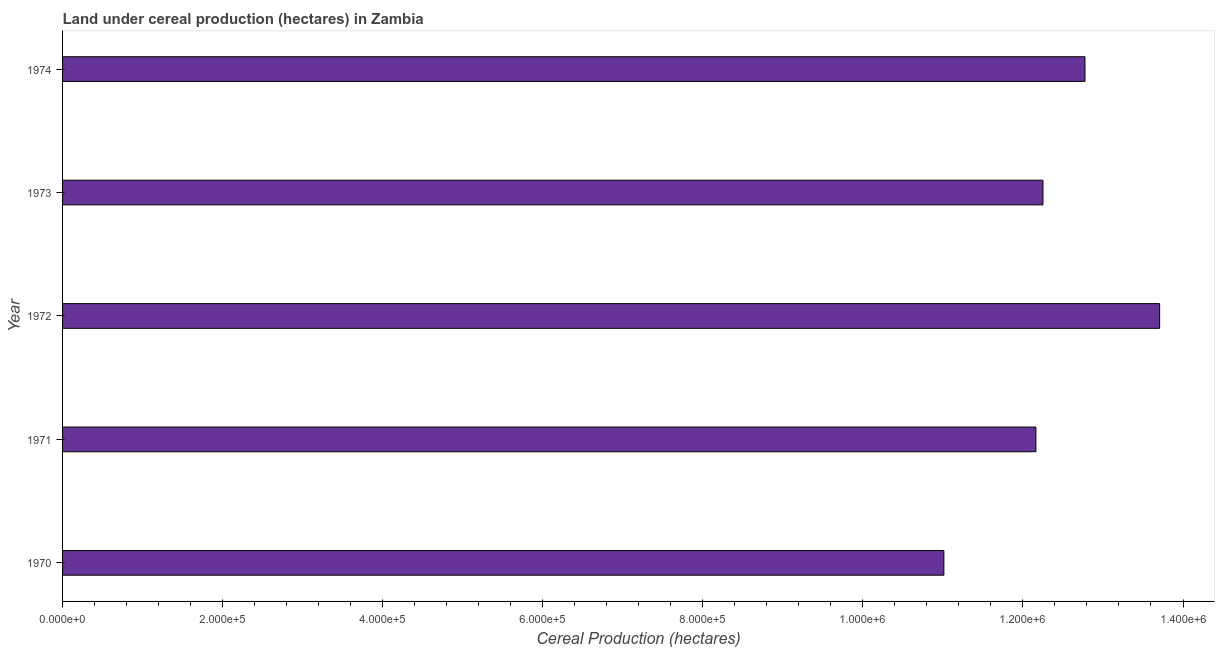What is the title of the graph?
Make the answer very short. Land under cereal production (hectares) in Zambia. What is the label or title of the X-axis?
Provide a short and direct response. Cereal Production (hectares). What is the land under cereal production in 1973?
Offer a very short reply. 1.22e+06. Across all years, what is the maximum land under cereal production?
Provide a short and direct response. 1.37e+06. Across all years, what is the minimum land under cereal production?
Your answer should be compact. 1.10e+06. In which year was the land under cereal production maximum?
Offer a terse response. 1972. What is the sum of the land under cereal production?
Provide a succinct answer. 6.19e+06. What is the difference between the land under cereal production in 1972 and 1974?
Your response must be concise. 9.33e+04. What is the average land under cereal production per year?
Ensure brevity in your answer.  1.24e+06. What is the median land under cereal production?
Make the answer very short. 1.22e+06. What is the difference between the highest and the second highest land under cereal production?
Ensure brevity in your answer.  9.33e+04. Is the sum of the land under cereal production in 1972 and 1973 greater than the maximum land under cereal production across all years?
Offer a very short reply. Yes. What is the difference between the highest and the lowest land under cereal production?
Provide a succinct answer. 2.70e+05. In how many years, is the land under cereal production greater than the average land under cereal production taken over all years?
Your answer should be very brief. 2. How many bars are there?
Your response must be concise. 5. What is the Cereal Production (hectares) of 1970?
Keep it short and to the point. 1.10e+06. What is the Cereal Production (hectares) of 1971?
Give a very brief answer. 1.22e+06. What is the Cereal Production (hectares) of 1972?
Provide a succinct answer. 1.37e+06. What is the Cereal Production (hectares) in 1973?
Ensure brevity in your answer.  1.22e+06. What is the Cereal Production (hectares) in 1974?
Give a very brief answer. 1.28e+06. What is the difference between the Cereal Production (hectares) in 1970 and 1971?
Provide a short and direct response. -1.15e+05. What is the difference between the Cereal Production (hectares) in 1970 and 1972?
Your answer should be very brief. -2.70e+05. What is the difference between the Cereal Production (hectares) in 1970 and 1973?
Your answer should be very brief. -1.24e+05. What is the difference between the Cereal Production (hectares) in 1970 and 1974?
Give a very brief answer. -1.76e+05. What is the difference between the Cereal Production (hectares) in 1971 and 1972?
Provide a short and direct response. -1.55e+05. What is the difference between the Cereal Production (hectares) in 1971 and 1973?
Make the answer very short. -8795. What is the difference between the Cereal Production (hectares) in 1971 and 1974?
Provide a succinct answer. -6.13e+04. What is the difference between the Cereal Production (hectares) in 1972 and 1973?
Offer a terse response. 1.46e+05. What is the difference between the Cereal Production (hectares) in 1972 and 1974?
Provide a short and direct response. 9.33e+04. What is the difference between the Cereal Production (hectares) in 1973 and 1974?
Make the answer very short. -5.25e+04. What is the ratio of the Cereal Production (hectares) in 1970 to that in 1971?
Your answer should be very brief. 0.91. What is the ratio of the Cereal Production (hectares) in 1970 to that in 1972?
Provide a short and direct response. 0.8. What is the ratio of the Cereal Production (hectares) in 1970 to that in 1973?
Give a very brief answer. 0.9. What is the ratio of the Cereal Production (hectares) in 1970 to that in 1974?
Offer a terse response. 0.86. What is the ratio of the Cereal Production (hectares) in 1971 to that in 1972?
Your answer should be very brief. 0.89. What is the ratio of the Cereal Production (hectares) in 1972 to that in 1973?
Offer a terse response. 1.12. What is the ratio of the Cereal Production (hectares) in 1972 to that in 1974?
Offer a terse response. 1.07. What is the ratio of the Cereal Production (hectares) in 1973 to that in 1974?
Offer a terse response. 0.96. 